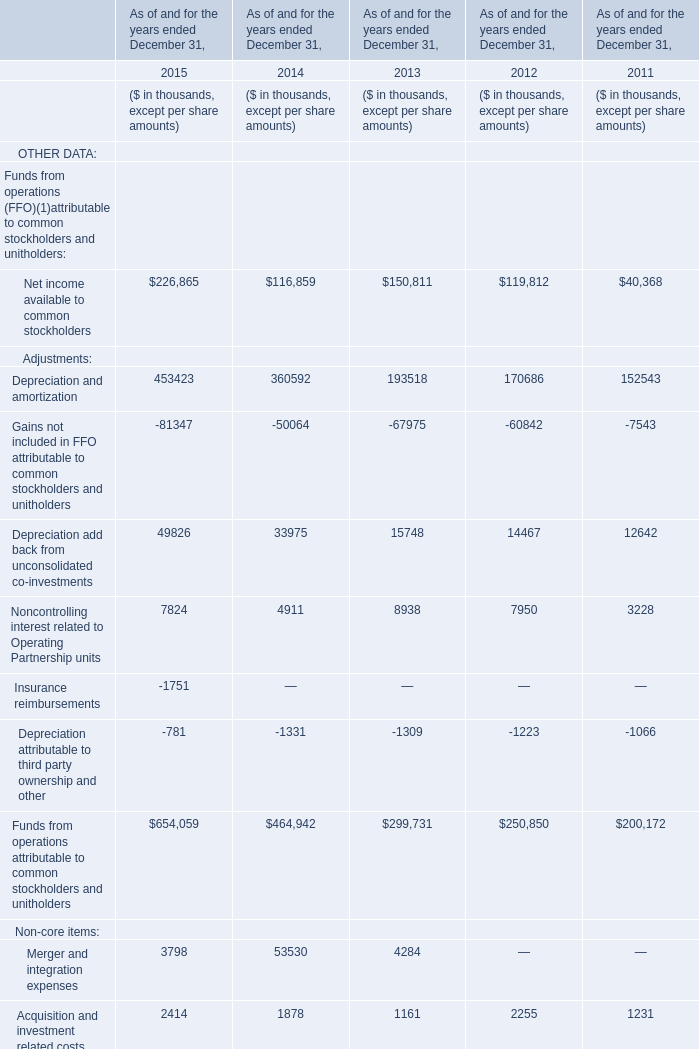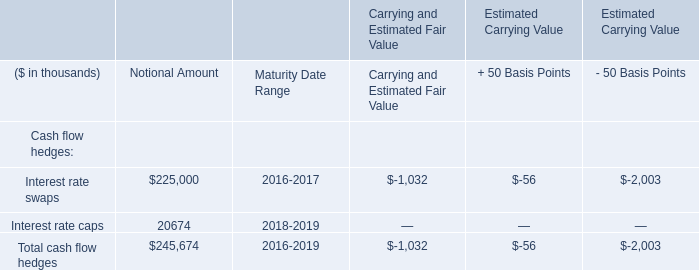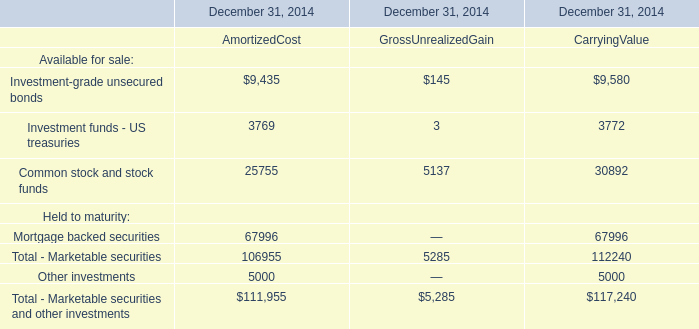Which year is Acquisition and investment related costs the lowest? 
Answer: 2013. 